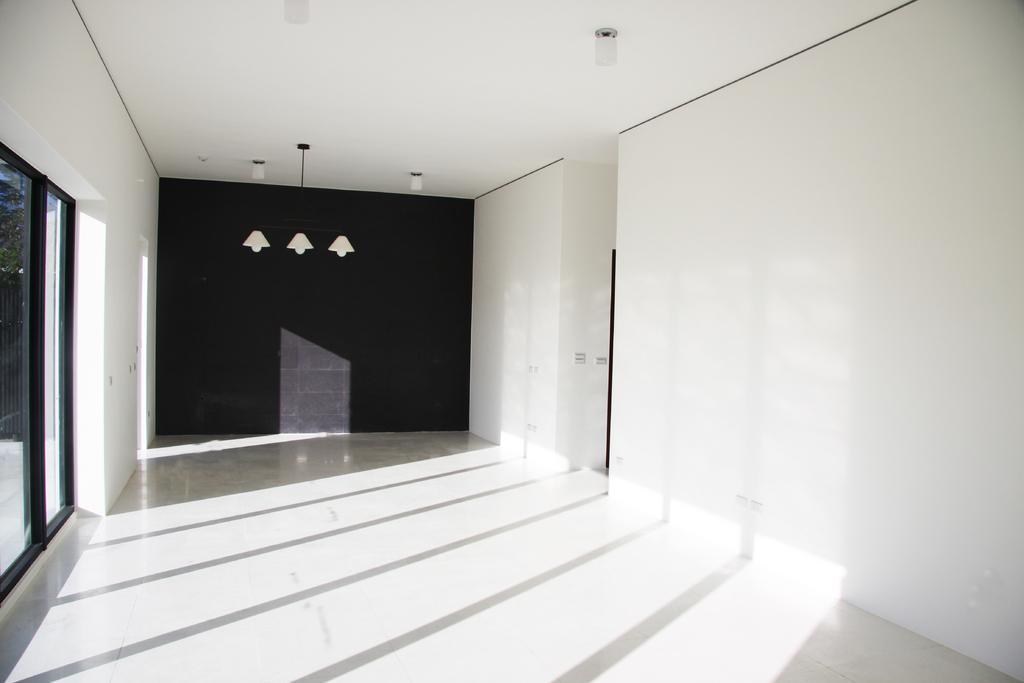How would you summarize this image in a sentence or two? This image is taken from inside. In this image we can see a floor. On the left side of the image there is a window. In the background there is a wall and a lamp. At the top of the image there is a ceiling. 